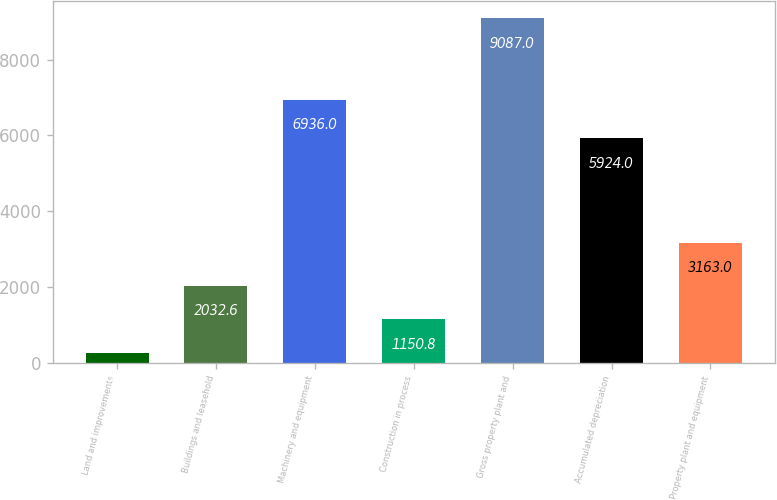<chart> <loc_0><loc_0><loc_500><loc_500><bar_chart><fcel>Land and improvements<fcel>Buildings and leasehold<fcel>Machinery and equipment<fcel>Construction in process<fcel>Gross property plant and<fcel>Accumulated depreciation<fcel>Property plant and equipment<nl><fcel>269<fcel>2032.6<fcel>6936<fcel>1150.8<fcel>9087<fcel>5924<fcel>3163<nl></chart> 